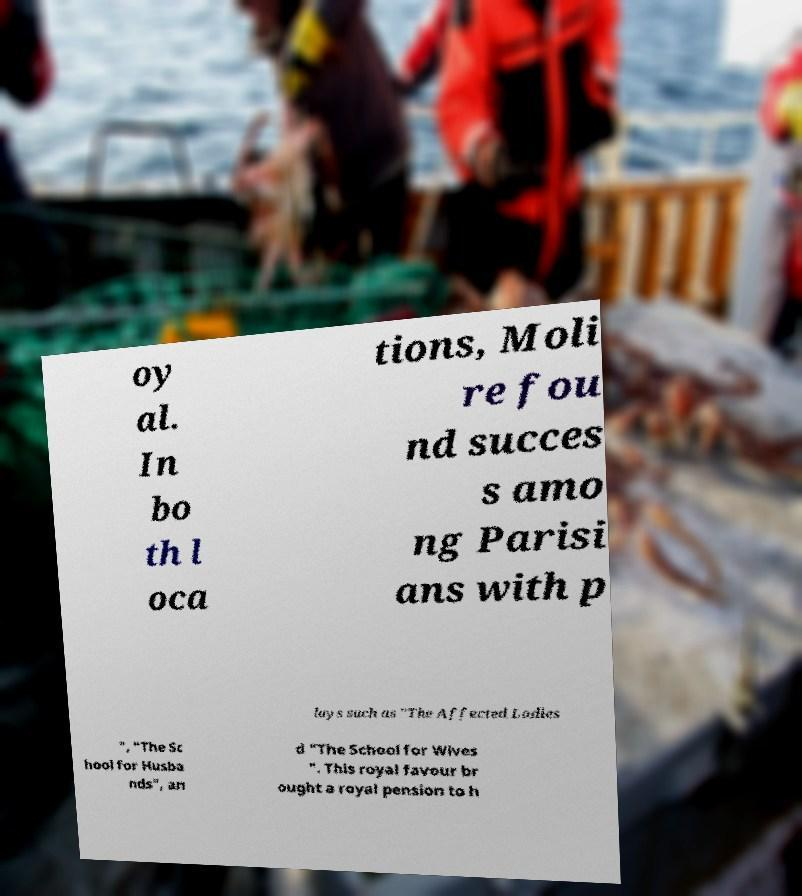Could you extract and type out the text from this image? oy al. In bo th l oca tions, Moli re fou nd succes s amo ng Parisi ans with p lays such as "The Affected Ladies ", "The Sc hool for Husba nds", an d "The School for Wives ". This royal favour br ought a royal pension to h 